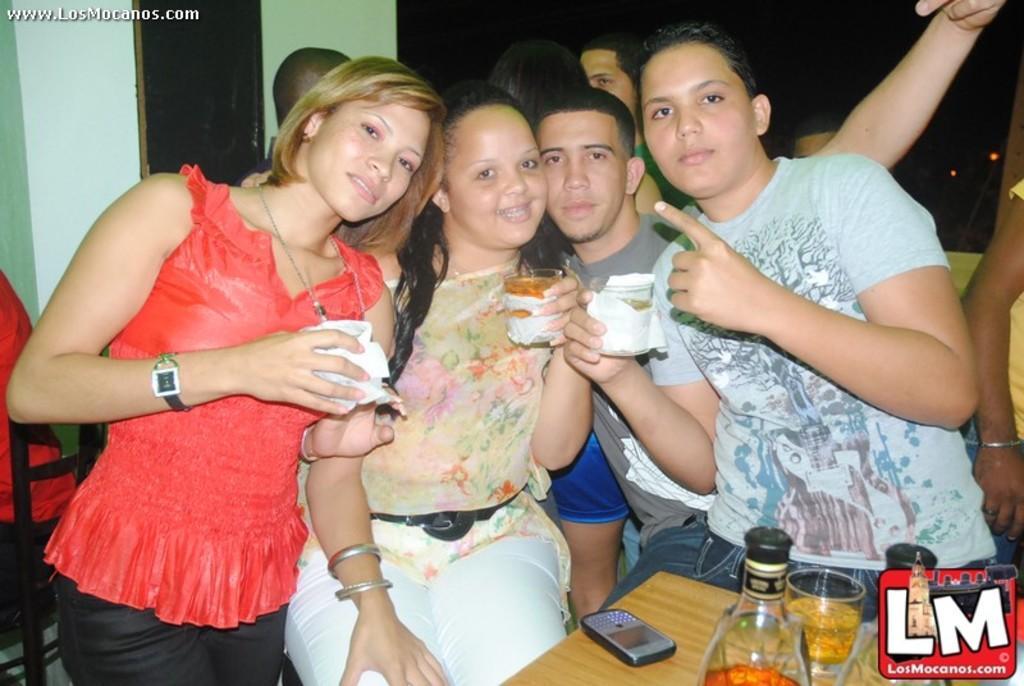How would you summarize this image in a sentence or two? In this image there are group of people in the middle who are holding the glasses. In front of them there is a table on which there is a mobile,glass and some wine bottles. 